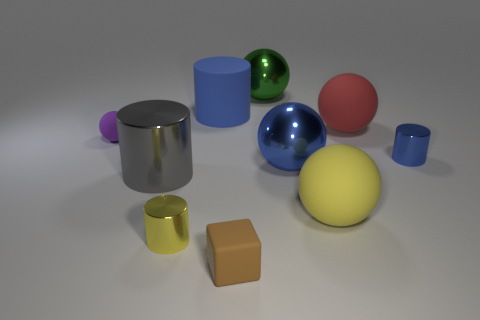Subtract all shiny cylinders. How many cylinders are left? 1 Subtract 2 spheres. How many spheres are left? 3 Subtract all red spheres. How many spheres are left? 4 Subtract all yellow blocks. How many cyan balls are left? 0 Add 7 yellow metal cylinders. How many yellow metal cylinders are left? 8 Add 5 small yellow objects. How many small yellow objects exist? 6 Subtract 1 green spheres. How many objects are left? 9 Subtract all cylinders. How many objects are left? 6 Subtract all red cubes. Subtract all blue cylinders. How many cubes are left? 1 Subtract all tiny rubber objects. Subtract all blue cylinders. How many objects are left? 6 